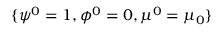<formula> <loc_0><loc_0><loc_500><loc_500>\{ \psi ^ { 0 } = 1 , \phi ^ { 0 } = 0 , \mu ^ { 0 } = \mu _ { 0 } \}</formula> 